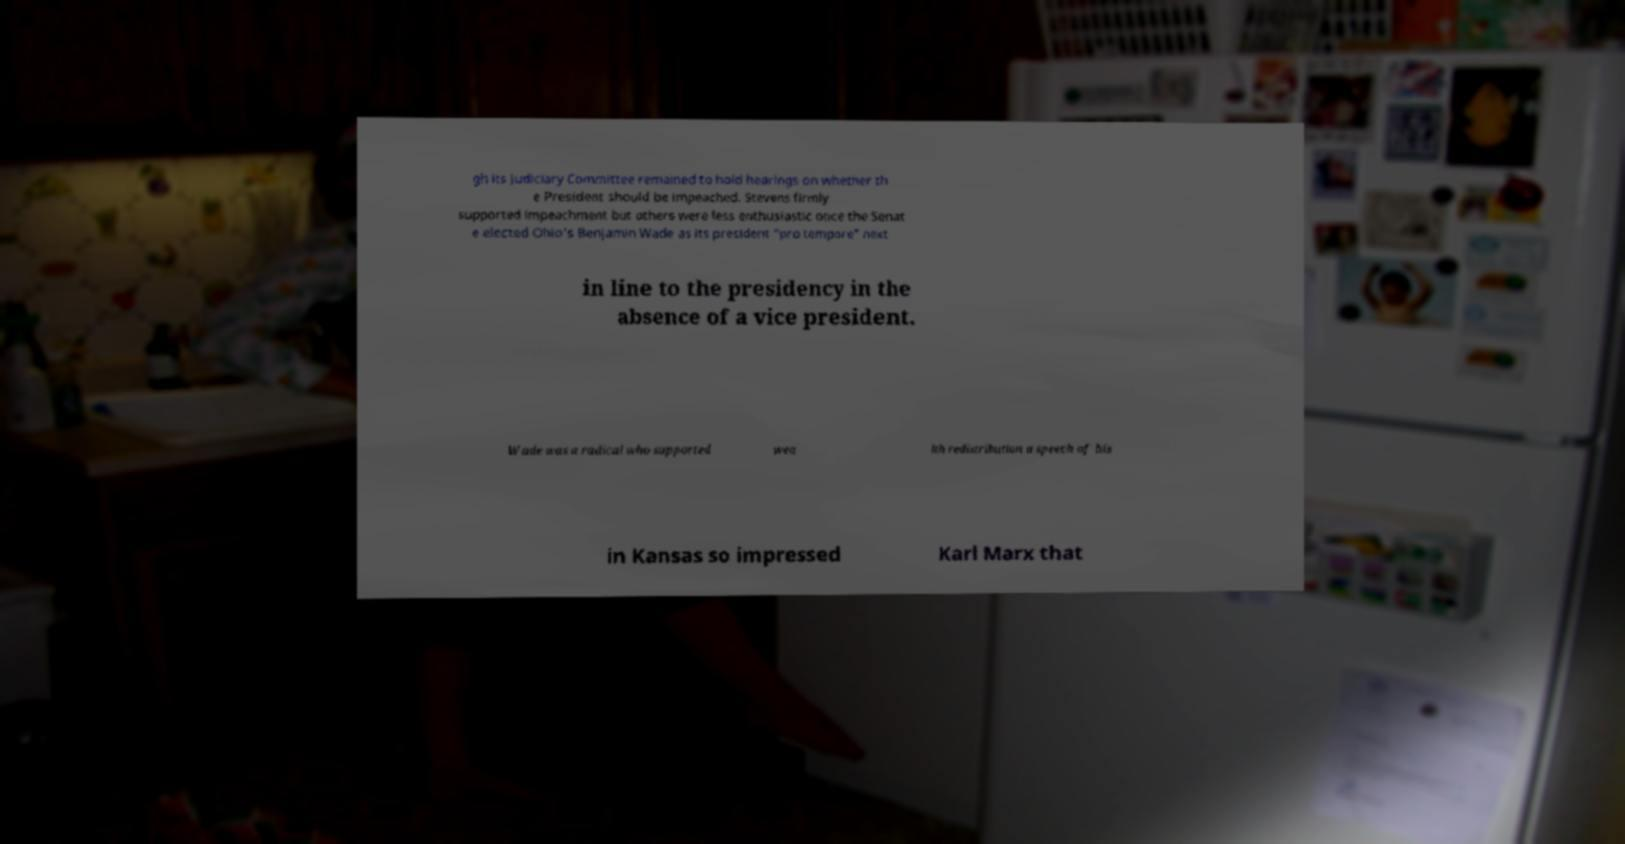For documentation purposes, I need the text within this image transcribed. Could you provide that? gh its Judiciary Committee remained to hold hearings on whether th e President should be impeached. Stevens firmly supported impeachment but others were less enthusiastic once the Senat e elected Ohio's Benjamin Wade as its president "pro tempore" next in line to the presidency in the absence of a vice president. Wade was a radical who supported wea lth redistribution a speech of his in Kansas so impressed Karl Marx that 